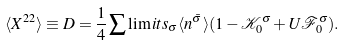<formula> <loc_0><loc_0><loc_500><loc_500>\langle X ^ { 2 2 } \rangle \equiv D = \frac { 1 } { 4 } \sum \lim i t s _ { \sigma } \langle n ^ { \bar { \sigma } } \rangle ( 1 - \mathcal { K } _ { 0 } ^ { \sigma } + U \mathcal { F } _ { 0 } ^ { \sigma } ) .</formula> 